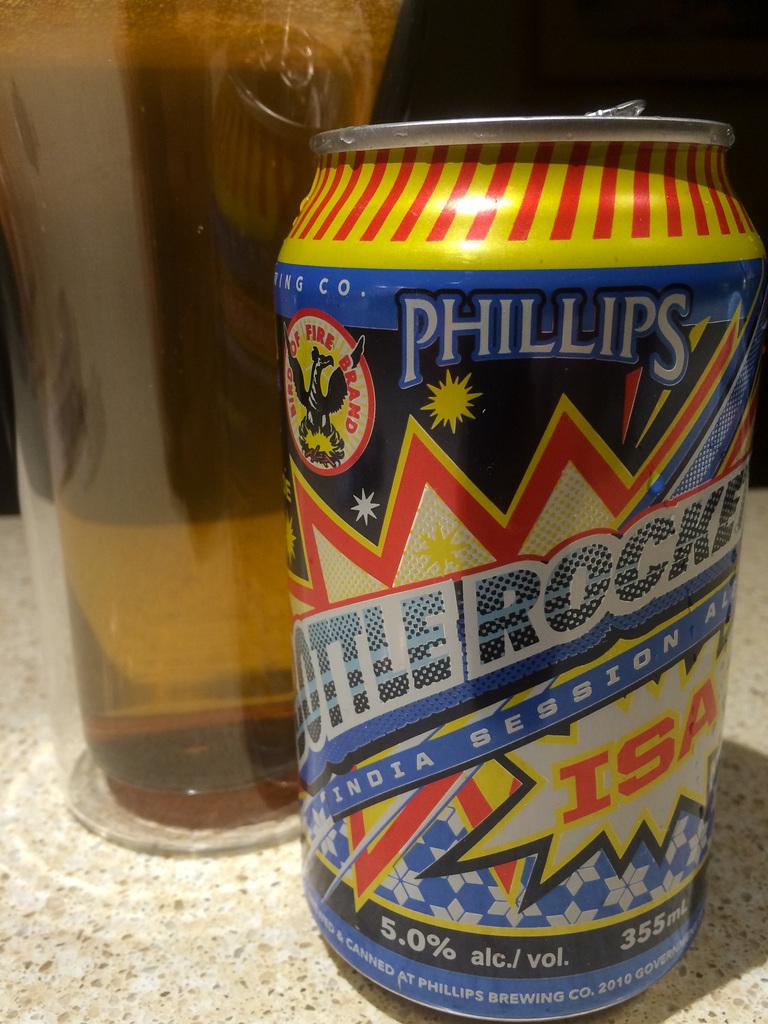<image>
Offer a succinct explanation of the picture presented. a phillips can that has some liquid in it 